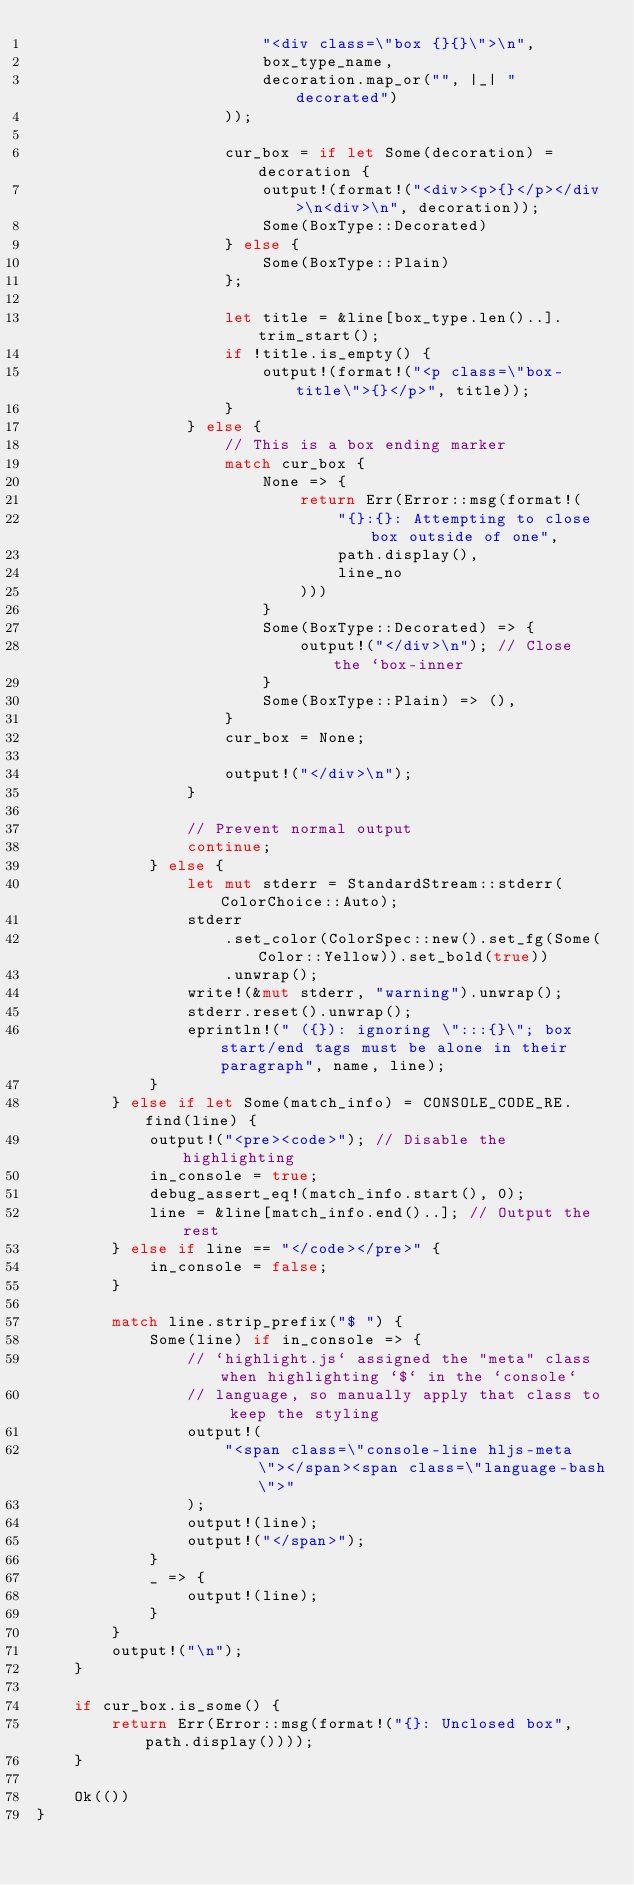Convert code to text. <code><loc_0><loc_0><loc_500><loc_500><_Rust_>                        "<div class=\"box {}{}\">\n",
                        box_type_name,
                        decoration.map_or("", |_| " decorated")
                    ));

                    cur_box = if let Some(decoration) = decoration {
                        output!(format!("<div><p>{}</p></div>\n<div>\n", decoration));
                        Some(BoxType::Decorated)
                    } else {
                        Some(BoxType::Plain)
                    };

                    let title = &line[box_type.len()..].trim_start();
                    if !title.is_empty() {
                        output!(format!("<p class=\"box-title\">{}</p>", title));
                    }
                } else {
                    // This is a box ending marker
                    match cur_box {
                        None => {
                            return Err(Error::msg(format!(
                                "{}:{}: Attempting to close box outside of one",
                                path.display(),
                                line_no
                            )))
                        }
                        Some(BoxType::Decorated) => {
                            output!("</div>\n"); // Close the `box-inner
                        }
                        Some(BoxType::Plain) => (),
                    }
                    cur_box = None;

                    output!("</div>\n");
                }

                // Prevent normal output
                continue;
            } else {
                let mut stderr = StandardStream::stderr(ColorChoice::Auto);
                stderr
                    .set_color(ColorSpec::new().set_fg(Some(Color::Yellow)).set_bold(true))
                    .unwrap();
                write!(&mut stderr, "warning").unwrap();
                stderr.reset().unwrap();
                eprintln!(" ({}): ignoring \":::{}\"; box start/end tags must be alone in their paragraph", name, line);
            }
        } else if let Some(match_info) = CONSOLE_CODE_RE.find(line) {
            output!("<pre><code>"); // Disable the highlighting
            in_console = true;
            debug_assert_eq!(match_info.start(), 0);
            line = &line[match_info.end()..]; // Output the rest
        } else if line == "</code></pre>" {
            in_console = false;
        }

        match line.strip_prefix("$ ") {
            Some(line) if in_console => {
                // `highlight.js` assigned the "meta" class when highlighting `$` in the `console`
                // language, so manually apply that class to keep the styling
                output!(
                    "<span class=\"console-line hljs-meta\"></span><span class=\"language-bash\">"
                );
                output!(line);
                output!("</span>");
            }
            _ => {
                output!(line);
            }
        }
        output!("\n");
    }

    if cur_box.is_some() {
        return Err(Error::msg(format!("{}: Unclosed box", path.display())));
    }

    Ok(())
}
</code> 